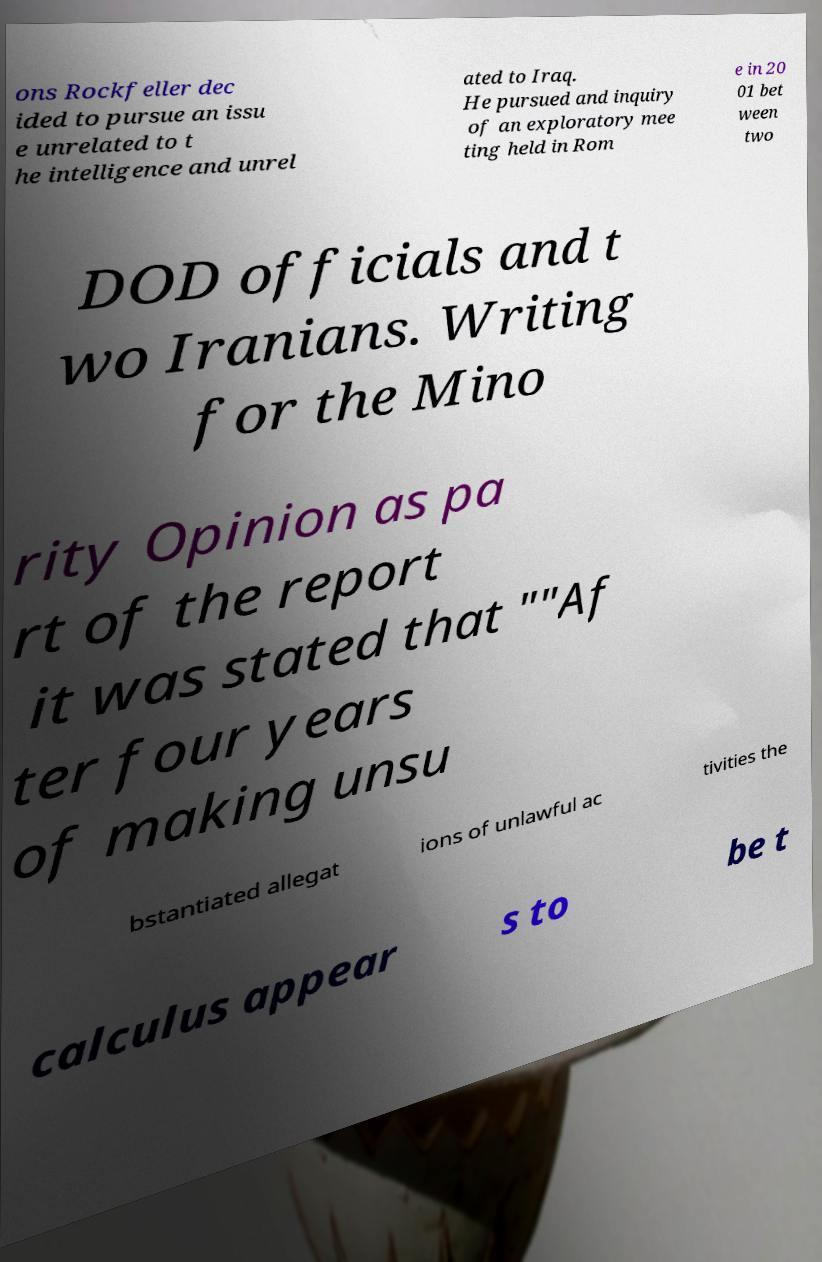There's text embedded in this image that I need extracted. Can you transcribe it verbatim? ons Rockfeller dec ided to pursue an issu e unrelated to t he intelligence and unrel ated to Iraq. He pursued and inquiry of an exploratory mee ting held in Rom e in 20 01 bet ween two DOD officials and t wo Iranians. Writing for the Mino rity Opinion as pa rt of the report it was stated that ""Af ter four years of making unsu bstantiated allegat ions of unlawful ac tivities the calculus appear s to be t 